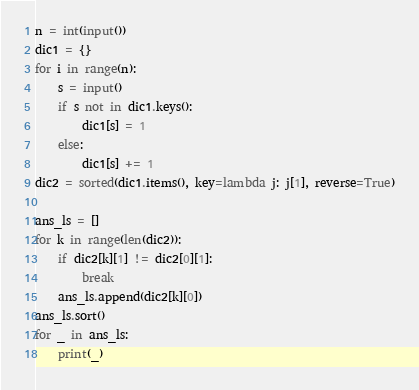Convert code to text. <code><loc_0><loc_0><loc_500><loc_500><_Python_>n = int(input())
dic1 = {}
for i in range(n):
    s = input()
    if s not in dic1.keys():
        dic1[s] = 1
    else:
        dic1[s] += 1
dic2 = sorted(dic1.items(), key=lambda j: j[1], reverse=True)

ans_ls = []
for k in range(len(dic2)):
    if dic2[k][1] != dic2[0][1]:
        break
    ans_ls.append(dic2[k][0])
ans_ls.sort()
for _ in ans_ls:
  	print(_)</code> 